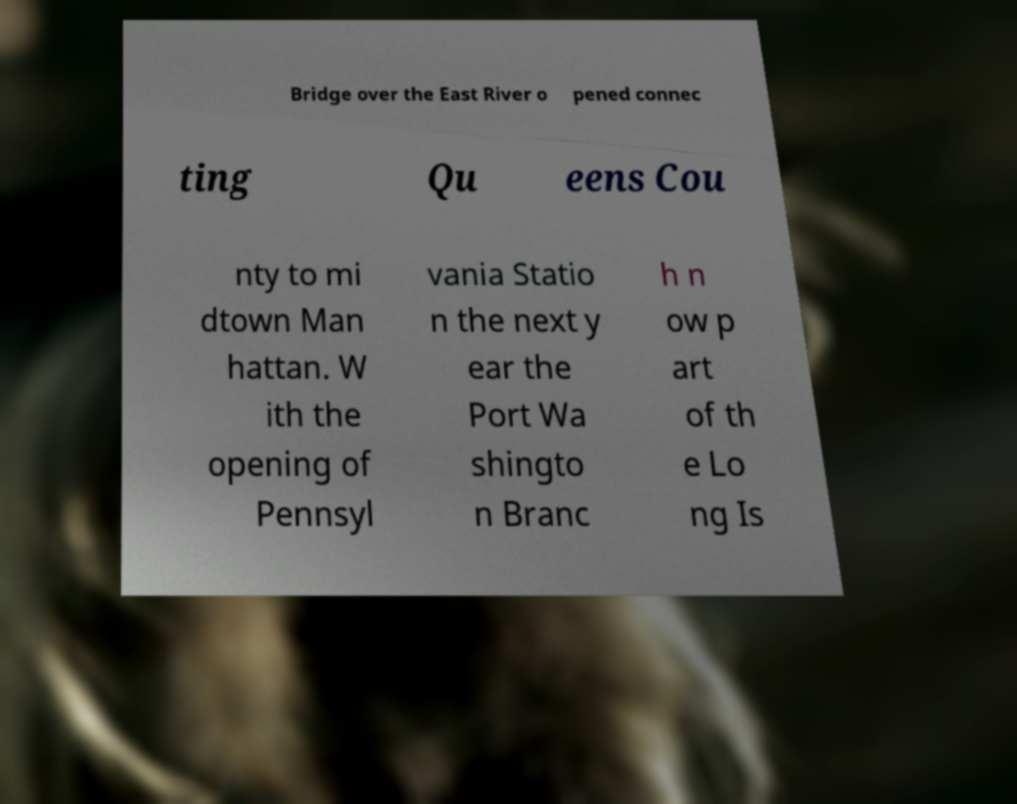Could you extract and type out the text from this image? Bridge over the East River o pened connec ting Qu eens Cou nty to mi dtown Man hattan. W ith the opening of Pennsyl vania Statio n the next y ear the Port Wa shingto n Branc h n ow p art of th e Lo ng Is 